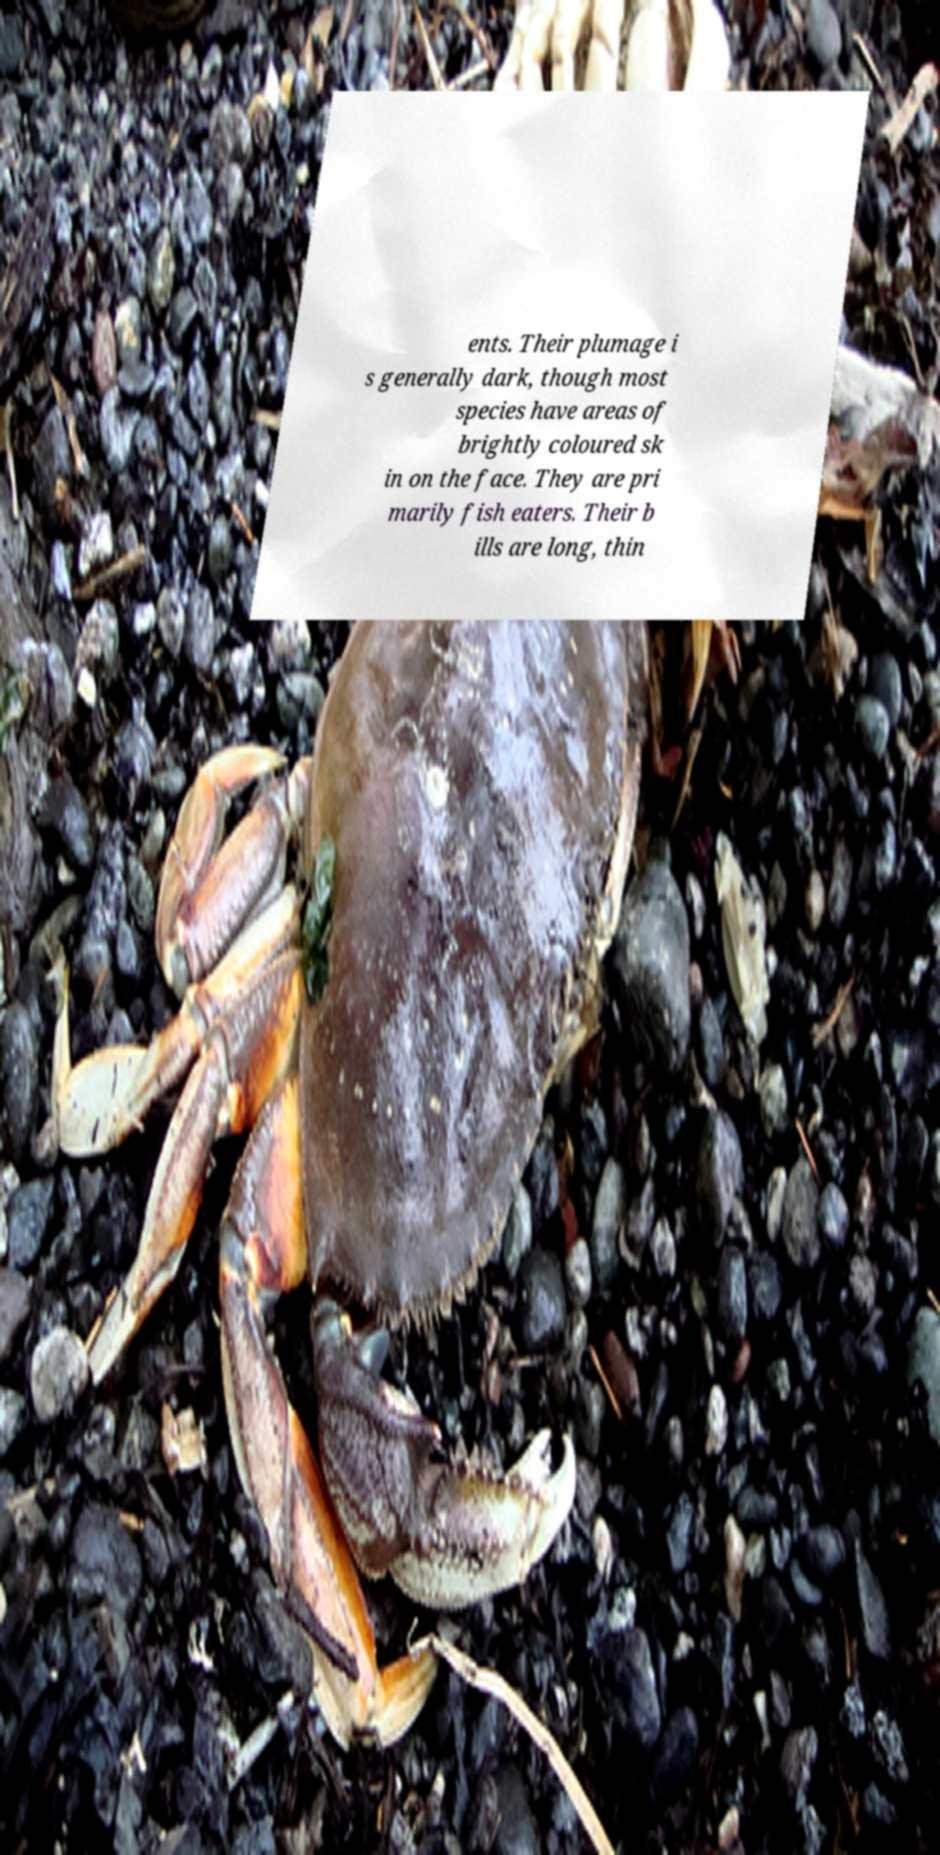Could you extract and type out the text from this image? ents. Their plumage i s generally dark, though most species have areas of brightly coloured sk in on the face. They are pri marily fish eaters. Their b ills are long, thin 